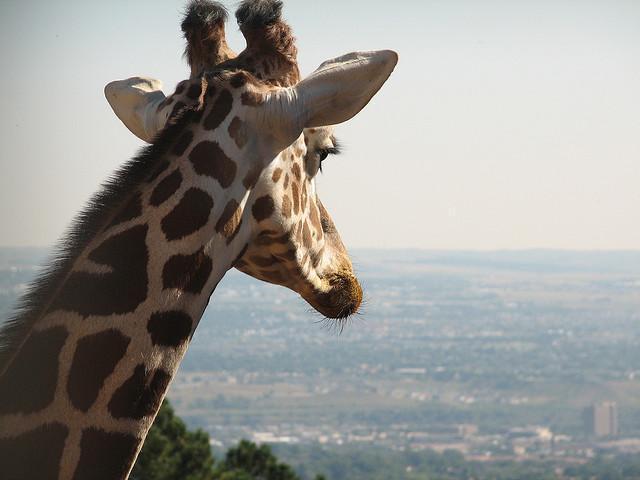How many giraffes can you see?
Give a very brief answer. 1. How many pieces of paper is the man with blue jeans holding?
Give a very brief answer. 0. 